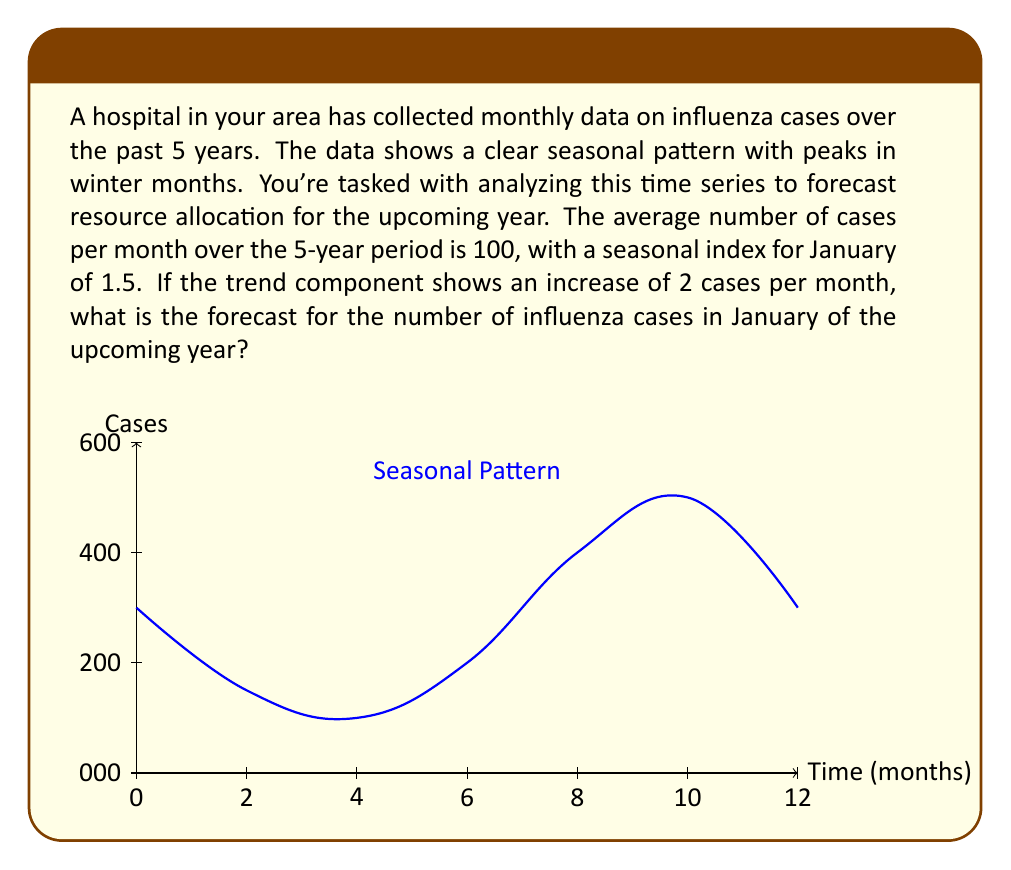Show me your answer to this math problem. To forecast the number of influenza cases, we'll use the multiplicative time series model:

$$Y_t = T_t \times S_t \times I_t$$

Where:
$Y_t$ is the forecast
$T_t$ is the trend component
$S_t$ is the seasonal component
$I_t$ is the irregular component (assumed to be 1 for forecasting)

1) Calculate the trend component ($T_t$):
   - Base: 100 cases per month
   - Increase: 2 cases per month
   - For 60 months (5 years): $100 + (60 \times 2) = 220$

2) Apply the seasonal index for January ($S_t$):
   - January's seasonal index: 1.5

3) Combine the components:
   $$Y_t = 220 \times 1.5 \times 1 = 330$$

Therefore, the forecast for January of the upcoming year is 330 cases.
Answer: 330 cases 